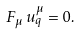<formula> <loc_0><loc_0><loc_500><loc_500>F _ { \mu } \, u _ { q } ^ { \mu } = 0 .</formula> 